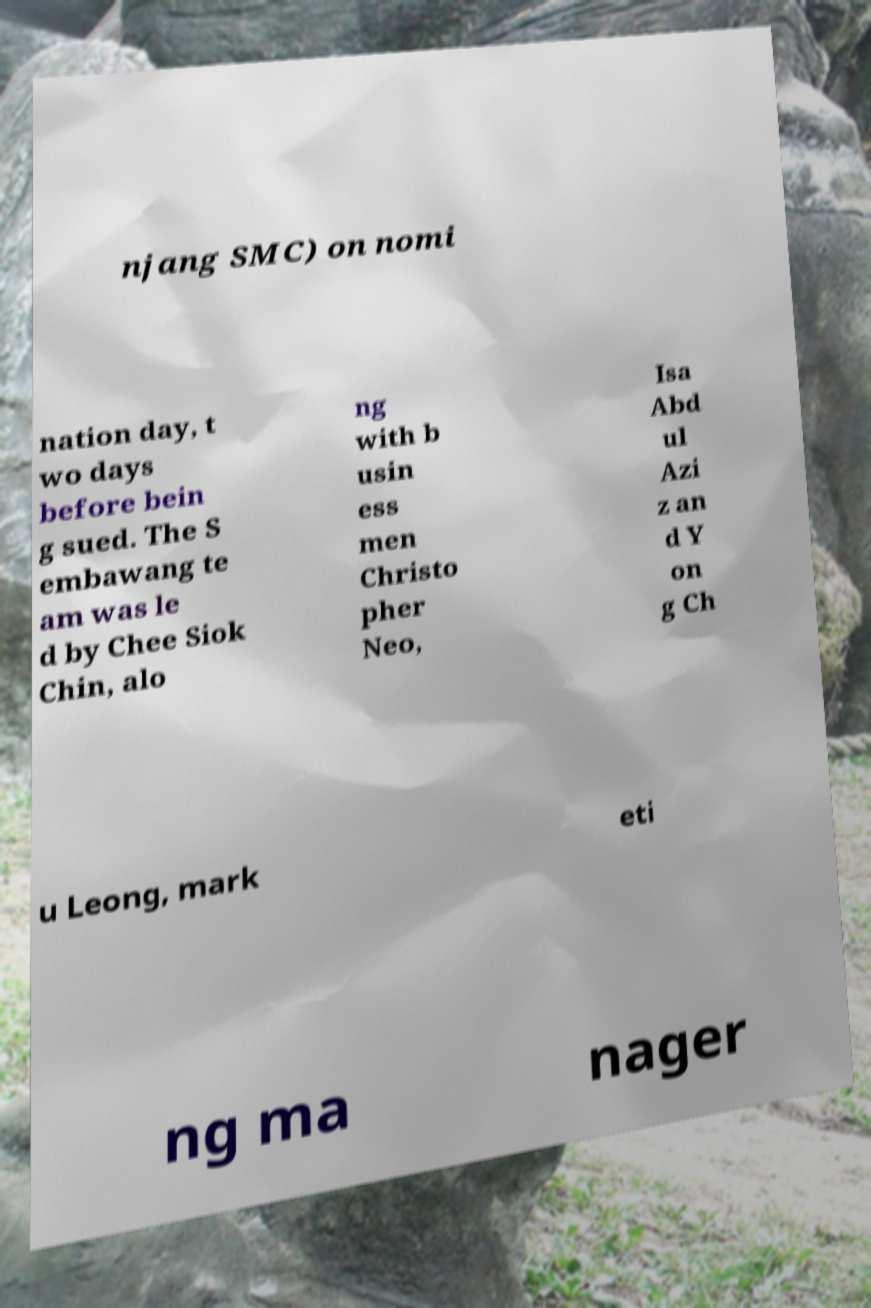Please read and relay the text visible in this image. What does it say? njang SMC) on nomi nation day, t wo days before bein g sued. The S embawang te am was le d by Chee Siok Chin, alo ng with b usin ess men Christo pher Neo, Isa Abd ul Azi z an d Y on g Ch u Leong, mark eti ng ma nager 